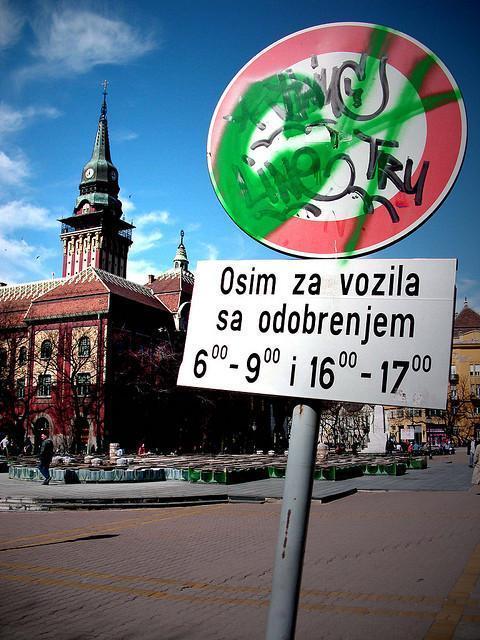How many languages are on the sign?
Give a very brief answer. 2. 